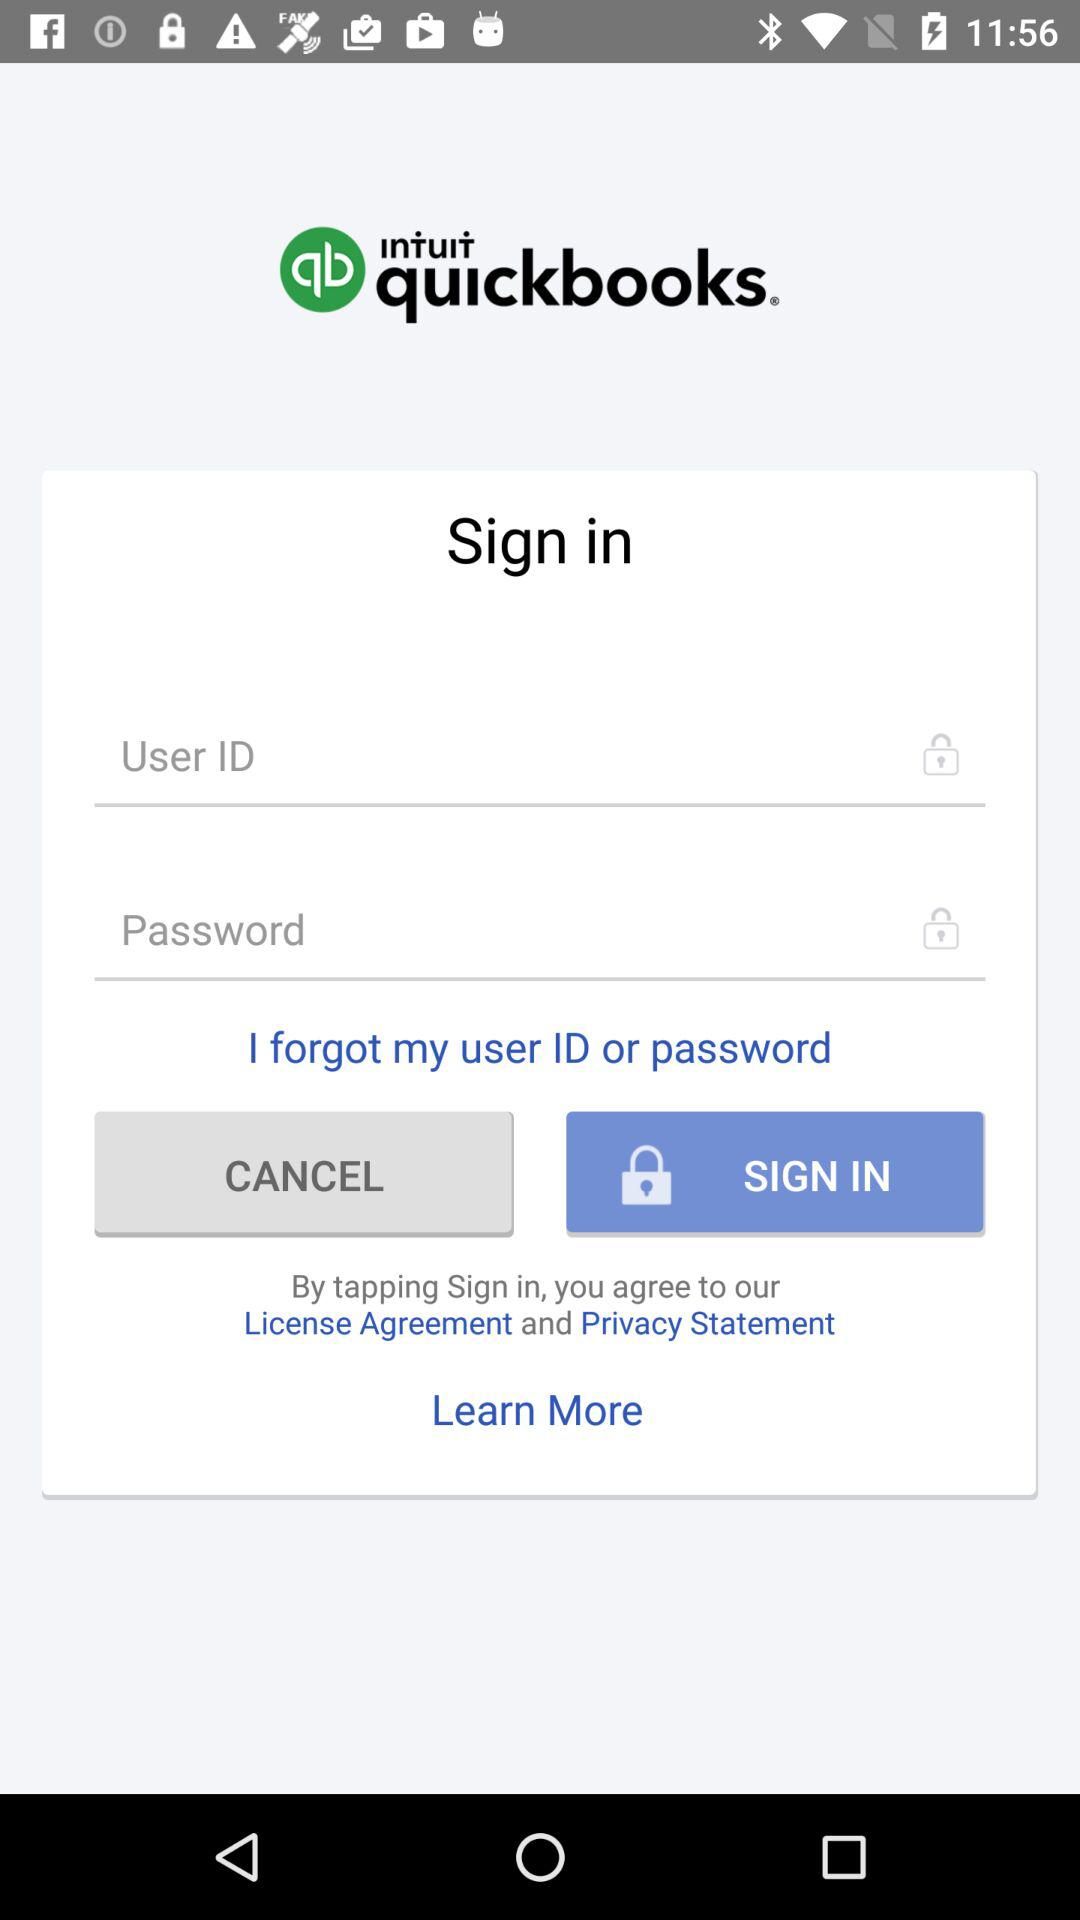How many text fields are there on this screen?
Answer the question using a single word or phrase. 2 